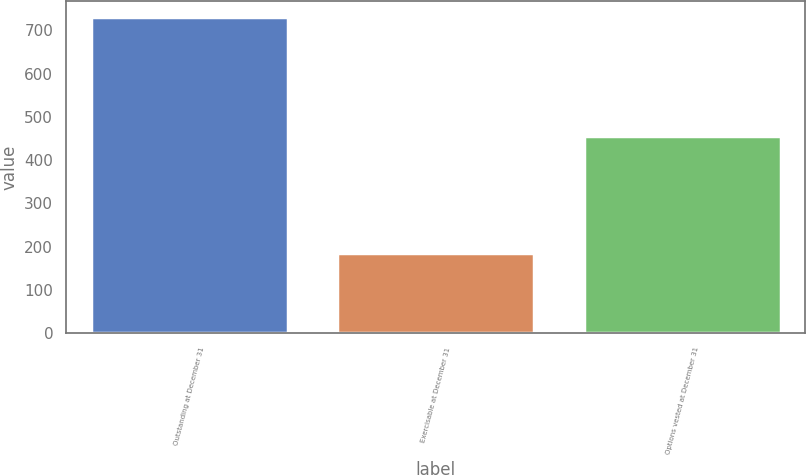Convert chart to OTSL. <chart><loc_0><loc_0><loc_500><loc_500><bar_chart><fcel>Outstanding at December 31<fcel>Exercisable at December 31<fcel>Options vested at December 31<nl><fcel>731<fcel>185<fcel>455<nl></chart> 